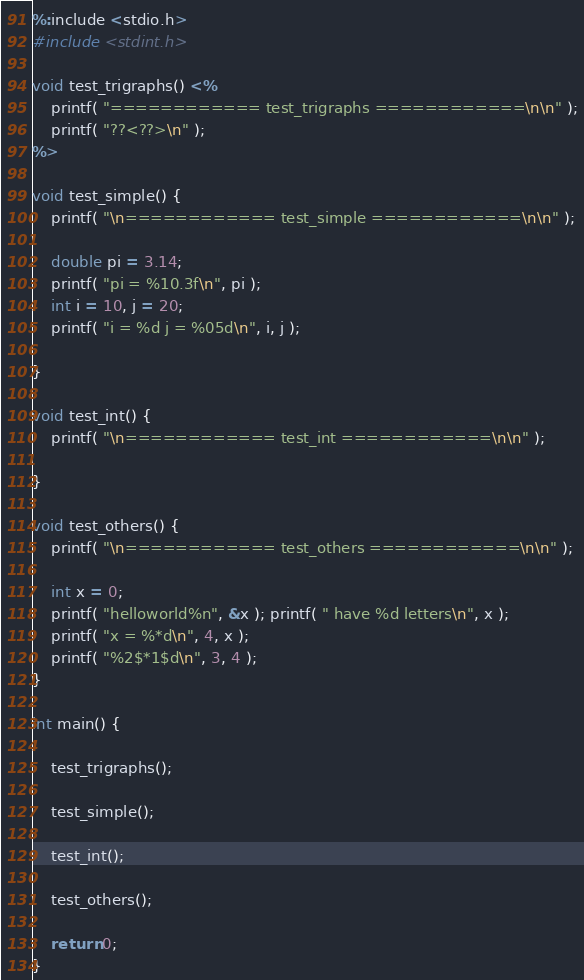<code> <loc_0><loc_0><loc_500><loc_500><_C++_>%:include <stdio.h>
#include <stdint.h>

void test_trigraphs() <%
	printf( "============ test_trigraphs ============\n\n" );
	printf( "??<??>\n" );
%>

void test_simple() {
	printf( "\n============ test_simple ============\n\n" );

	double pi = 3.14;
	printf( "pi = %10.3f\n", pi );
	int i = 10, j = 20;
	printf( "i = %d j = %05d\n", i, j );

}

void test_int() {
	printf( "\n============ test_int ============\n\n" );

}

void test_others() {
	printf( "\n============ test_others ============\n\n" );

	int x = 0;
	printf( "helloworld%n", &x ); printf( " have %d letters\n", x );
	printf( "x = %*d\n", 4, x );
	printf( "%2$*1$d\n", 3, 4 );
}

int main() {

	test_trigraphs();

	test_simple();

	test_int();

	test_others();	

	return 0;
}
</code> 